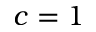<formula> <loc_0><loc_0><loc_500><loc_500>c = 1</formula> 